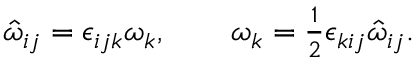<formula> <loc_0><loc_0><loc_500><loc_500>\begin{array} { r } { \hat { \omega } _ { i j } = \epsilon _ { i j k } \omega _ { k } , \quad \omega _ { k } = \frac { 1 } { 2 } \epsilon _ { k i j } \hat { \omega } _ { i j } . } \end{array}</formula> 